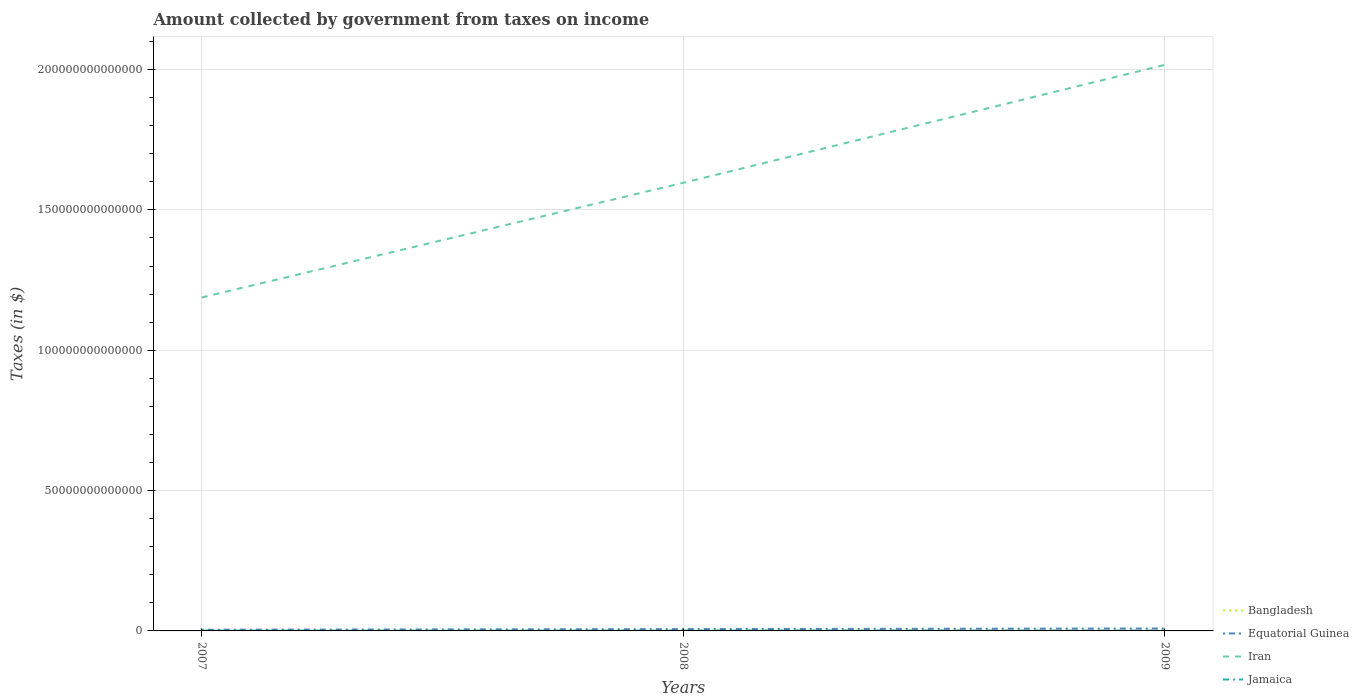Across all years, what is the maximum amount collected by government from taxes on income in Bangladesh?
Keep it short and to the point. 8.62e+1. In which year was the amount collected by government from taxes on income in Bangladesh maximum?
Your answer should be compact. 2007. What is the total amount collected by government from taxes on income in Iran in the graph?
Offer a terse response. -4.08e+13. What is the difference between the highest and the second highest amount collected by government from taxes on income in Iran?
Keep it short and to the point. 8.29e+13. How many lines are there?
Provide a succinct answer. 4. What is the difference between two consecutive major ticks on the Y-axis?
Give a very brief answer. 5.00e+13. Are the values on the major ticks of Y-axis written in scientific E-notation?
Keep it short and to the point. No. Does the graph contain grids?
Offer a very short reply. Yes. What is the title of the graph?
Your response must be concise. Amount collected by government from taxes on income. Does "Hungary" appear as one of the legend labels in the graph?
Provide a short and direct response. No. What is the label or title of the X-axis?
Offer a terse response. Years. What is the label or title of the Y-axis?
Provide a succinct answer. Taxes (in $). What is the Taxes (in $) in Bangladesh in 2007?
Offer a very short reply. 8.62e+1. What is the Taxes (in $) of Equatorial Guinea in 2007?
Give a very brief answer. 4.24e+11. What is the Taxes (in $) of Iran in 2007?
Your response must be concise. 1.19e+14. What is the Taxes (in $) of Jamaica in 2007?
Your answer should be compact. 1.03e+11. What is the Taxes (in $) of Bangladesh in 2008?
Your answer should be compact. 1.17e+11. What is the Taxes (in $) of Equatorial Guinea in 2008?
Provide a succinct answer. 6.47e+11. What is the Taxes (in $) in Iran in 2008?
Keep it short and to the point. 1.60e+14. What is the Taxes (in $) of Jamaica in 2008?
Keep it short and to the point. 1.19e+11. What is the Taxes (in $) of Bangladesh in 2009?
Provide a succinct answer. 1.34e+11. What is the Taxes (in $) in Equatorial Guinea in 2009?
Make the answer very short. 8.46e+11. What is the Taxes (in $) in Iran in 2009?
Provide a succinct answer. 2.02e+14. What is the Taxes (in $) in Jamaica in 2009?
Offer a very short reply. 1.31e+11. Across all years, what is the maximum Taxes (in $) of Bangladesh?
Ensure brevity in your answer.  1.34e+11. Across all years, what is the maximum Taxes (in $) of Equatorial Guinea?
Your answer should be very brief. 8.46e+11. Across all years, what is the maximum Taxes (in $) of Iran?
Give a very brief answer. 2.02e+14. Across all years, what is the maximum Taxes (in $) in Jamaica?
Keep it short and to the point. 1.31e+11. Across all years, what is the minimum Taxes (in $) in Bangladesh?
Ensure brevity in your answer.  8.62e+1. Across all years, what is the minimum Taxes (in $) of Equatorial Guinea?
Provide a short and direct response. 4.24e+11. Across all years, what is the minimum Taxes (in $) of Iran?
Make the answer very short. 1.19e+14. Across all years, what is the minimum Taxes (in $) in Jamaica?
Your response must be concise. 1.03e+11. What is the total Taxes (in $) of Bangladesh in the graph?
Keep it short and to the point. 3.37e+11. What is the total Taxes (in $) in Equatorial Guinea in the graph?
Keep it short and to the point. 1.92e+12. What is the total Taxes (in $) in Iran in the graph?
Keep it short and to the point. 4.80e+14. What is the total Taxes (in $) of Jamaica in the graph?
Your answer should be compact. 3.53e+11. What is the difference between the Taxes (in $) of Bangladesh in 2007 and that in 2008?
Give a very brief answer. -3.05e+1. What is the difference between the Taxes (in $) in Equatorial Guinea in 2007 and that in 2008?
Provide a short and direct response. -2.23e+11. What is the difference between the Taxes (in $) of Iran in 2007 and that in 2008?
Ensure brevity in your answer.  -4.08e+13. What is the difference between the Taxes (in $) of Jamaica in 2007 and that in 2008?
Make the answer very short. -1.63e+1. What is the difference between the Taxes (in $) in Bangladesh in 2007 and that in 2009?
Make the answer very short. -4.81e+1. What is the difference between the Taxes (in $) of Equatorial Guinea in 2007 and that in 2009?
Your response must be concise. -4.22e+11. What is the difference between the Taxes (in $) of Iran in 2007 and that in 2009?
Make the answer very short. -8.29e+13. What is the difference between the Taxes (in $) in Jamaica in 2007 and that in 2009?
Your answer should be very brief. -2.79e+1. What is the difference between the Taxes (in $) of Bangladesh in 2008 and that in 2009?
Your answer should be compact. -1.76e+1. What is the difference between the Taxes (in $) of Equatorial Guinea in 2008 and that in 2009?
Keep it short and to the point. -1.99e+11. What is the difference between the Taxes (in $) in Iran in 2008 and that in 2009?
Provide a succinct answer. -4.20e+13. What is the difference between the Taxes (in $) in Jamaica in 2008 and that in 2009?
Ensure brevity in your answer.  -1.16e+1. What is the difference between the Taxes (in $) in Bangladesh in 2007 and the Taxes (in $) in Equatorial Guinea in 2008?
Give a very brief answer. -5.60e+11. What is the difference between the Taxes (in $) in Bangladesh in 2007 and the Taxes (in $) in Iran in 2008?
Your answer should be compact. -1.60e+14. What is the difference between the Taxes (in $) of Bangladesh in 2007 and the Taxes (in $) of Jamaica in 2008?
Your answer should be compact. -3.29e+1. What is the difference between the Taxes (in $) of Equatorial Guinea in 2007 and the Taxes (in $) of Iran in 2008?
Offer a very short reply. -1.59e+14. What is the difference between the Taxes (in $) in Equatorial Guinea in 2007 and the Taxes (in $) in Jamaica in 2008?
Provide a short and direct response. 3.05e+11. What is the difference between the Taxes (in $) of Iran in 2007 and the Taxes (in $) of Jamaica in 2008?
Ensure brevity in your answer.  1.19e+14. What is the difference between the Taxes (in $) of Bangladesh in 2007 and the Taxes (in $) of Equatorial Guinea in 2009?
Offer a very short reply. -7.60e+11. What is the difference between the Taxes (in $) of Bangladesh in 2007 and the Taxes (in $) of Iran in 2009?
Ensure brevity in your answer.  -2.02e+14. What is the difference between the Taxes (in $) of Bangladesh in 2007 and the Taxes (in $) of Jamaica in 2009?
Keep it short and to the point. -4.45e+1. What is the difference between the Taxes (in $) in Equatorial Guinea in 2007 and the Taxes (in $) in Iran in 2009?
Your answer should be compact. -2.01e+14. What is the difference between the Taxes (in $) in Equatorial Guinea in 2007 and the Taxes (in $) in Jamaica in 2009?
Provide a succinct answer. 2.93e+11. What is the difference between the Taxes (in $) of Iran in 2007 and the Taxes (in $) of Jamaica in 2009?
Your answer should be compact. 1.19e+14. What is the difference between the Taxes (in $) in Bangladesh in 2008 and the Taxes (in $) in Equatorial Guinea in 2009?
Your answer should be compact. -7.29e+11. What is the difference between the Taxes (in $) of Bangladesh in 2008 and the Taxes (in $) of Iran in 2009?
Ensure brevity in your answer.  -2.02e+14. What is the difference between the Taxes (in $) in Bangladesh in 2008 and the Taxes (in $) in Jamaica in 2009?
Provide a short and direct response. -1.41e+1. What is the difference between the Taxes (in $) in Equatorial Guinea in 2008 and the Taxes (in $) in Iran in 2009?
Offer a terse response. -2.01e+14. What is the difference between the Taxes (in $) in Equatorial Guinea in 2008 and the Taxes (in $) in Jamaica in 2009?
Your answer should be very brief. 5.16e+11. What is the difference between the Taxes (in $) in Iran in 2008 and the Taxes (in $) in Jamaica in 2009?
Provide a short and direct response. 1.60e+14. What is the average Taxes (in $) of Bangladesh per year?
Your answer should be very brief. 1.12e+11. What is the average Taxes (in $) in Equatorial Guinea per year?
Keep it short and to the point. 6.39e+11. What is the average Taxes (in $) of Iran per year?
Give a very brief answer. 1.60e+14. What is the average Taxes (in $) in Jamaica per year?
Keep it short and to the point. 1.18e+11. In the year 2007, what is the difference between the Taxes (in $) of Bangladesh and Taxes (in $) of Equatorial Guinea?
Ensure brevity in your answer.  -3.38e+11. In the year 2007, what is the difference between the Taxes (in $) in Bangladesh and Taxes (in $) in Iran?
Offer a very short reply. -1.19e+14. In the year 2007, what is the difference between the Taxes (in $) in Bangladesh and Taxes (in $) in Jamaica?
Ensure brevity in your answer.  -1.67e+1. In the year 2007, what is the difference between the Taxes (in $) of Equatorial Guinea and Taxes (in $) of Iran?
Ensure brevity in your answer.  -1.18e+14. In the year 2007, what is the difference between the Taxes (in $) of Equatorial Guinea and Taxes (in $) of Jamaica?
Your response must be concise. 3.21e+11. In the year 2007, what is the difference between the Taxes (in $) of Iran and Taxes (in $) of Jamaica?
Your answer should be compact. 1.19e+14. In the year 2008, what is the difference between the Taxes (in $) in Bangladesh and Taxes (in $) in Equatorial Guinea?
Provide a succinct answer. -5.30e+11. In the year 2008, what is the difference between the Taxes (in $) of Bangladesh and Taxes (in $) of Iran?
Your response must be concise. -1.60e+14. In the year 2008, what is the difference between the Taxes (in $) in Bangladesh and Taxes (in $) in Jamaica?
Your response must be concise. -2.48e+09. In the year 2008, what is the difference between the Taxes (in $) in Equatorial Guinea and Taxes (in $) in Iran?
Provide a short and direct response. -1.59e+14. In the year 2008, what is the difference between the Taxes (in $) in Equatorial Guinea and Taxes (in $) in Jamaica?
Your answer should be very brief. 5.27e+11. In the year 2008, what is the difference between the Taxes (in $) in Iran and Taxes (in $) in Jamaica?
Ensure brevity in your answer.  1.60e+14. In the year 2009, what is the difference between the Taxes (in $) in Bangladesh and Taxes (in $) in Equatorial Guinea?
Ensure brevity in your answer.  -7.12e+11. In the year 2009, what is the difference between the Taxes (in $) of Bangladesh and Taxes (in $) of Iran?
Provide a short and direct response. -2.02e+14. In the year 2009, what is the difference between the Taxes (in $) of Bangladesh and Taxes (in $) of Jamaica?
Give a very brief answer. 3.57e+09. In the year 2009, what is the difference between the Taxes (in $) in Equatorial Guinea and Taxes (in $) in Iran?
Provide a succinct answer. -2.01e+14. In the year 2009, what is the difference between the Taxes (in $) of Equatorial Guinea and Taxes (in $) of Jamaica?
Your response must be concise. 7.15e+11. In the year 2009, what is the difference between the Taxes (in $) of Iran and Taxes (in $) of Jamaica?
Your answer should be very brief. 2.02e+14. What is the ratio of the Taxes (in $) of Bangladesh in 2007 to that in 2008?
Your response must be concise. 0.74. What is the ratio of the Taxes (in $) in Equatorial Guinea in 2007 to that in 2008?
Keep it short and to the point. 0.66. What is the ratio of the Taxes (in $) in Iran in 2007 to that in 2008?
Ensure brevity in your answer.  0.74. What is the ratio of the Taxes (in $) of Jamaica in 2007 to that in 2008?
Your response must be concise. 0.86. What is the ratio of the Taxes (in $) in Bangladesh in 2007 to that in 2009?
Your response must be concise. 0.64. What is the ratio of the Taxes (in $) of Equatorial Guinea in 2007 to that in 2009?
Offer a terse response. 0.5. What is the ratio of the Taxes (in $) in Iran in 2007 to that in 2009?
Give a very brief answer. 0.59. What is the ratio of the Taxes (in $) in Jamaica in 2007 to that in 2009?
Your answer should be compact. 0.79. What is the ratio of the Taxes (in $) of Bangladesh in 2008 to that in 2009?
Provide a succinct answer. 0.87. What is the ratio of the Taxes (in $) in Equatorial Guinea in 2008 to that in 2009?
Make the answer very short. 0.76. What is the ratio of the Taxes (in $) in Iran in 2008 to that in 2009?
Provide a short and direct response. 0.79. What is the ratio of the Taxes (in $) in Jamaica in 2008 to that in 2009?
Keep it short and to the point. 0.91. What is the difference between the highest and the second highest Taxes (in $) in Bangladesh?
Provide a succinct answer. 1.76e+1. What is the difference between the highest and the second highest Taxes (in $) of Equatorial Guinea?
Your answer should be compact. 1.99e+11. What is the difference between the highest and the second highest Taxes (in $) in Iran?
Your response must be concise. 4.20e+13. What is the difference between the highest and the second highest Taxes (in $) of Jamaica?
Offer a terse response. 1.16e+1. What is the difference between the highest and the lowest Taxes (in $) of Bangladesh?
Offer a very short reply. 4.81e+1. What is the difference between the highest and the lowest Taxes (in $) of Equatorial Guinea?
Your answer should be compact. 4.22e+11. What is the difference between the highest and the lowest Taxes (in $) in Iran?
Give a very brief answer. 8.29e+13. What is the difference between the highest and the lowest Taxes (in $) of Jamaica?
Give a very brief answer. 2.79e+1. 